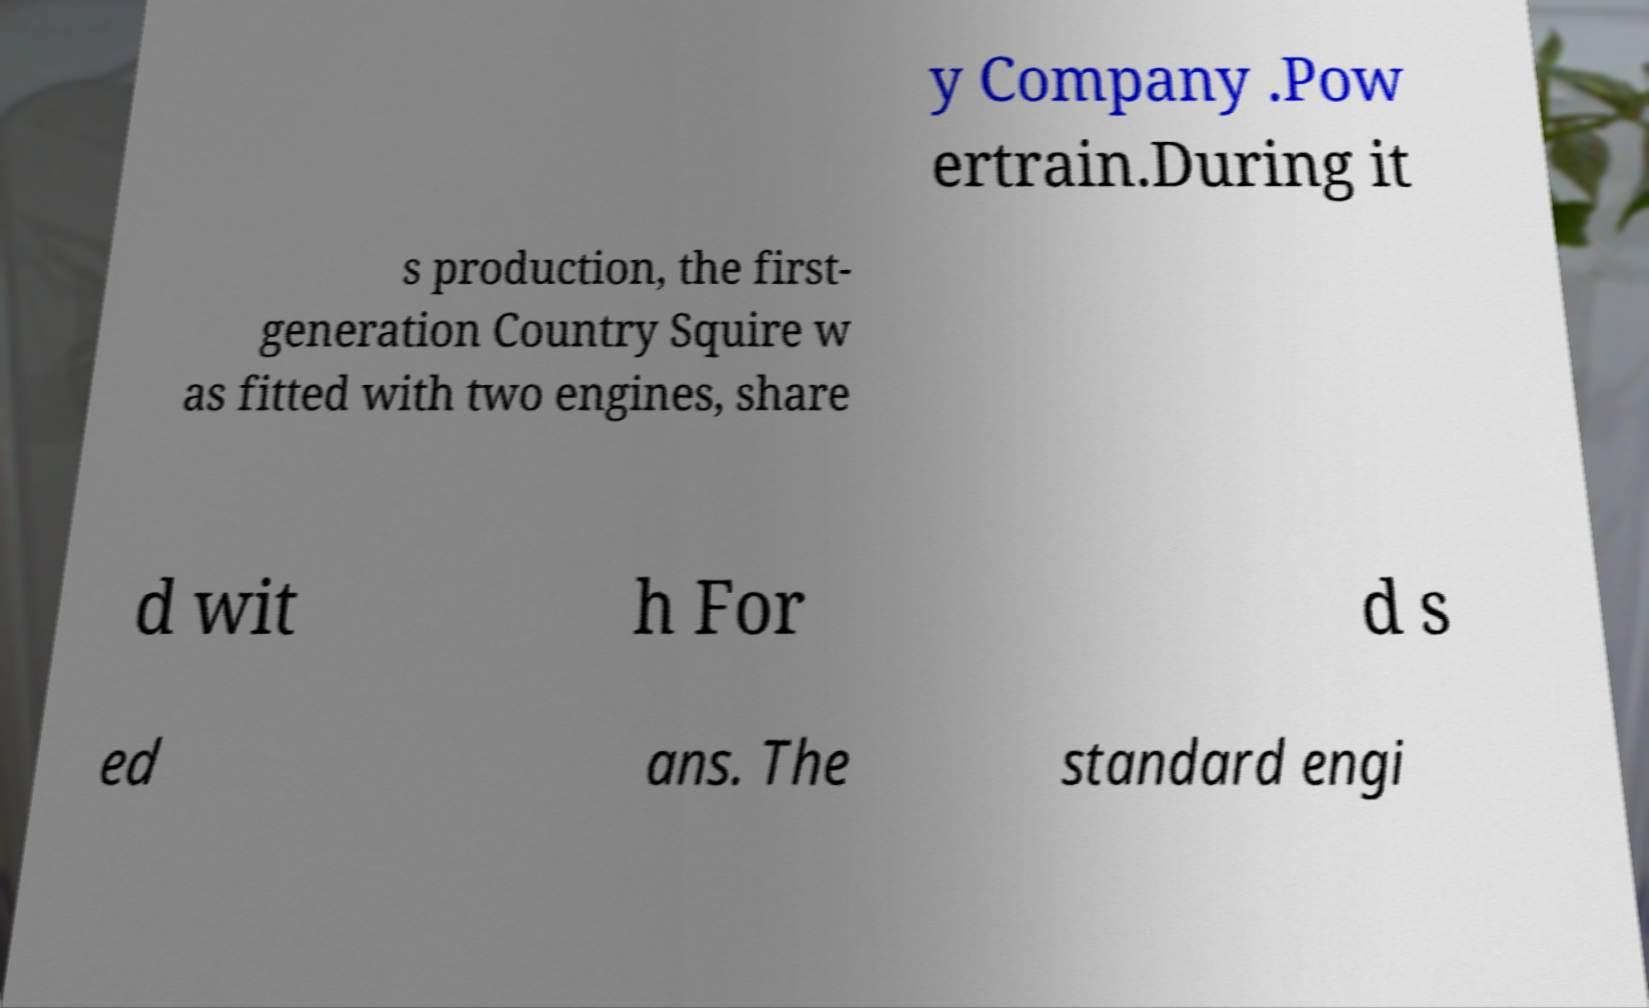For documentation purposes, I need the text within this image transcribed. Could you provide that? y Company .Pow ertrain.During it s production, the first- generation Country Squire w as fitted with two engines, share d wit h For d s ed ans. The standard engi 